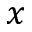<formula> <loc_0><loc_0><loc_500><loc_500>x</formula> 